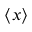<formula> <loc_0><loc_0><loc_500><loc_500>\langle x \rangle</formula> 